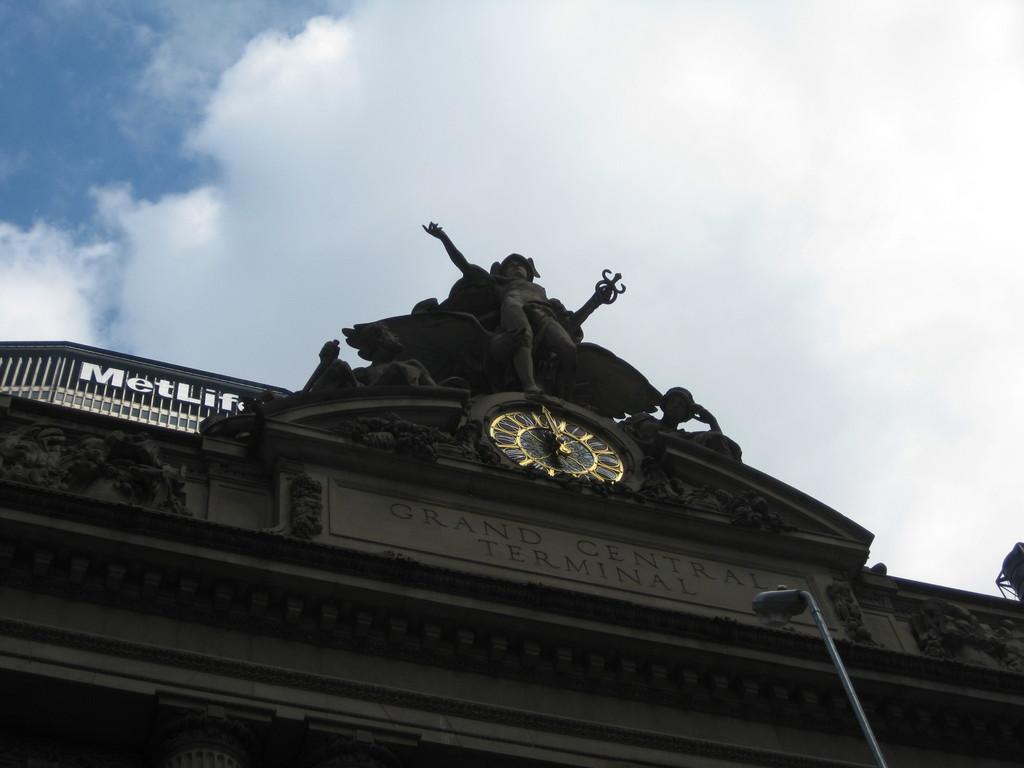What type of structure is present in the image? There is a building in the image. What can be seen on the building? There is a name board on the building. What time-telling device is visible in the image? There is a clock in the image. What type of artwork is present in the image? There is a statue in the image. What type of street infrastructure is present in the image? There is a street pole and a street light in the image. What can be seen in the background of the image? The sky with clouds is visible in the background of the image. What type of vegetable is being used as a decoration on the street pole in the image? There is no vegetable present on the street pole in the image. How many divisions are there in the clock in the image? The clock in the image does not have divisions; it is a single, continuous circle. 